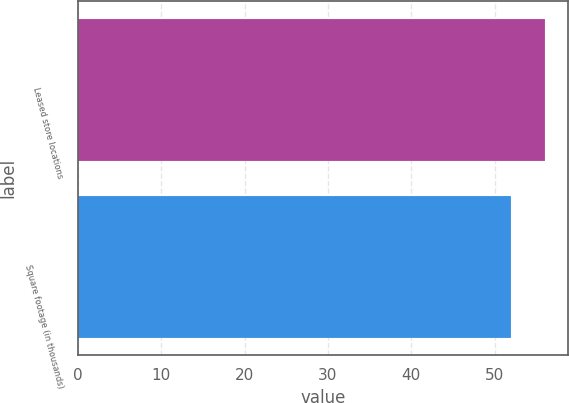Convert chart. <chart><loc_0><loc_0><loc_500><loc_500><bar_chart><fcel>Leased store locations<fcel>Square footage (in thousands)<nl><fcel>56<fcel>52<nl></chart> 